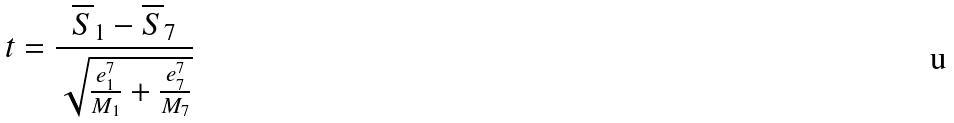<formula> <loc_0><loc_0><loc_500><loc_500>t = \frac { \overline { S } _ { 1 } - \overline { S } _ { 7 } } { \sqrt { \frac { e _ { 1 } ^ { 7 } } { M _ { 1 } } + \frac { e _ { 7 } ^ { 7 } } { M _ { 7 } } } }</formula> 